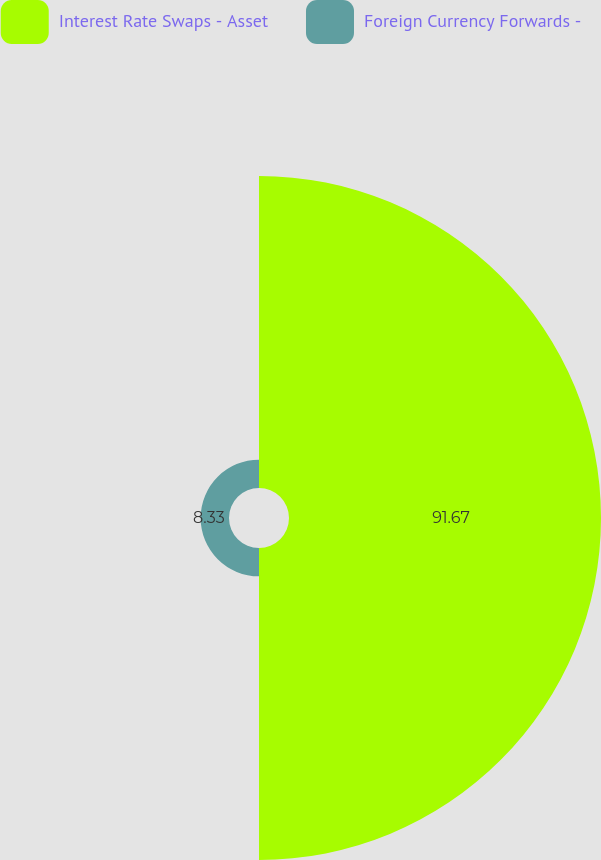Convert chart to OTSL. <chart><loc_0><loc_0><loc_500><loc_500><pie_chart><fcel>Interest Rate Swaps - Asset<fcel>Foreign Currency Forwards -<nl><fcel>91.67%<fcel>8.33%<nl></chart> 